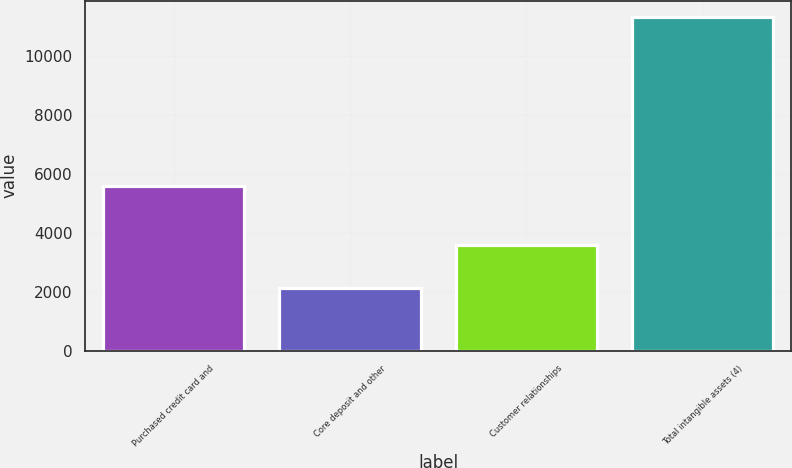<chart> <loc_0><loc_0><loc_500><loc_500><bar_chart><fcel>Purchased credit card and<fcel>Core deposit and other<fcel>Customer relationships<fcel>Total intangible assets (4)<nl><fcel>5604<fcel>2140<fcel>3584<fcel>11328<nl></chart> 